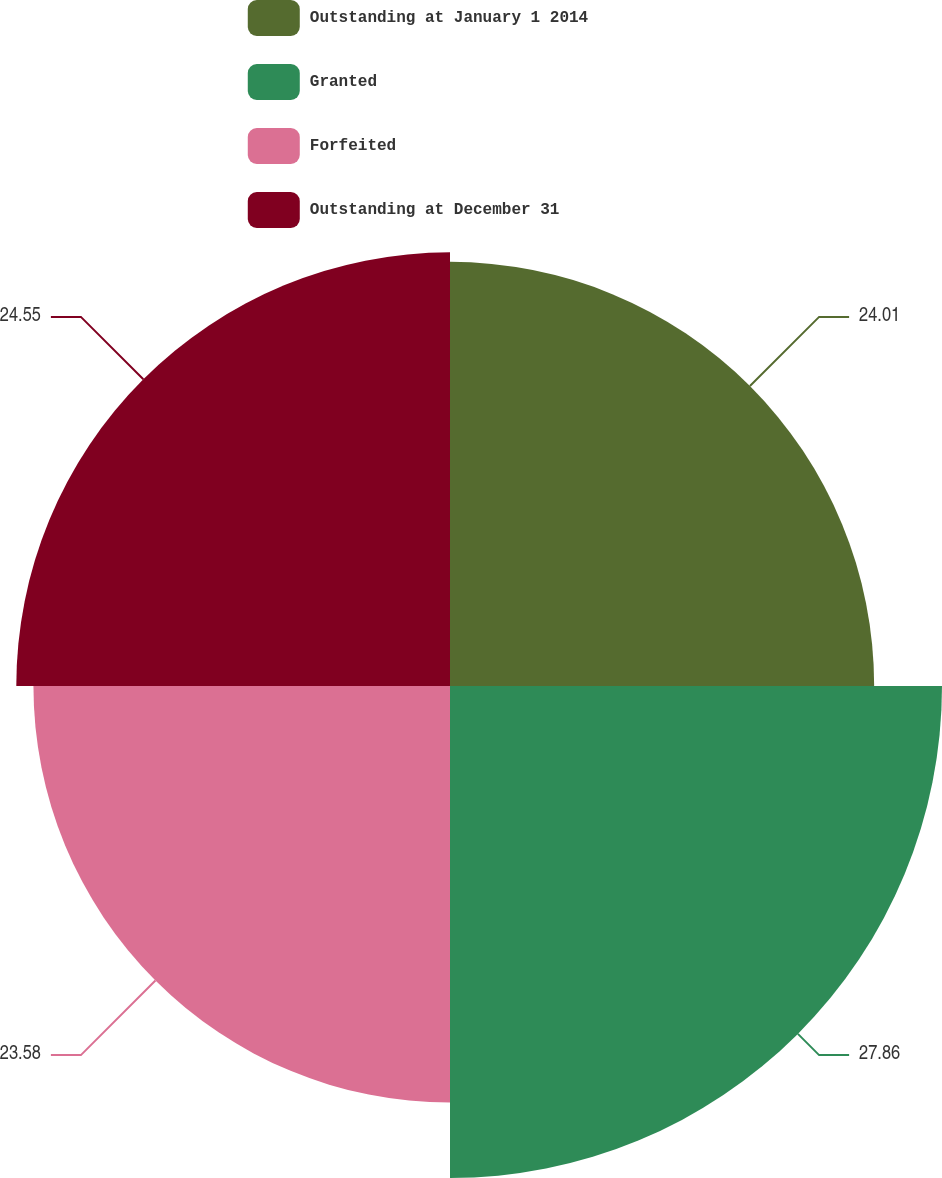<chart> <loc_0><loc_0><loc_500><loc_500><pie_chart><fcel>Outstanding at January 1 2014<fcel>Granted<fcel>Forfeited<fcel>Outstanding at December 31<nl><fcel>24.01%<fcel>27.85%<fcel>23.58%<fcel>24.55%<nl></chart> 